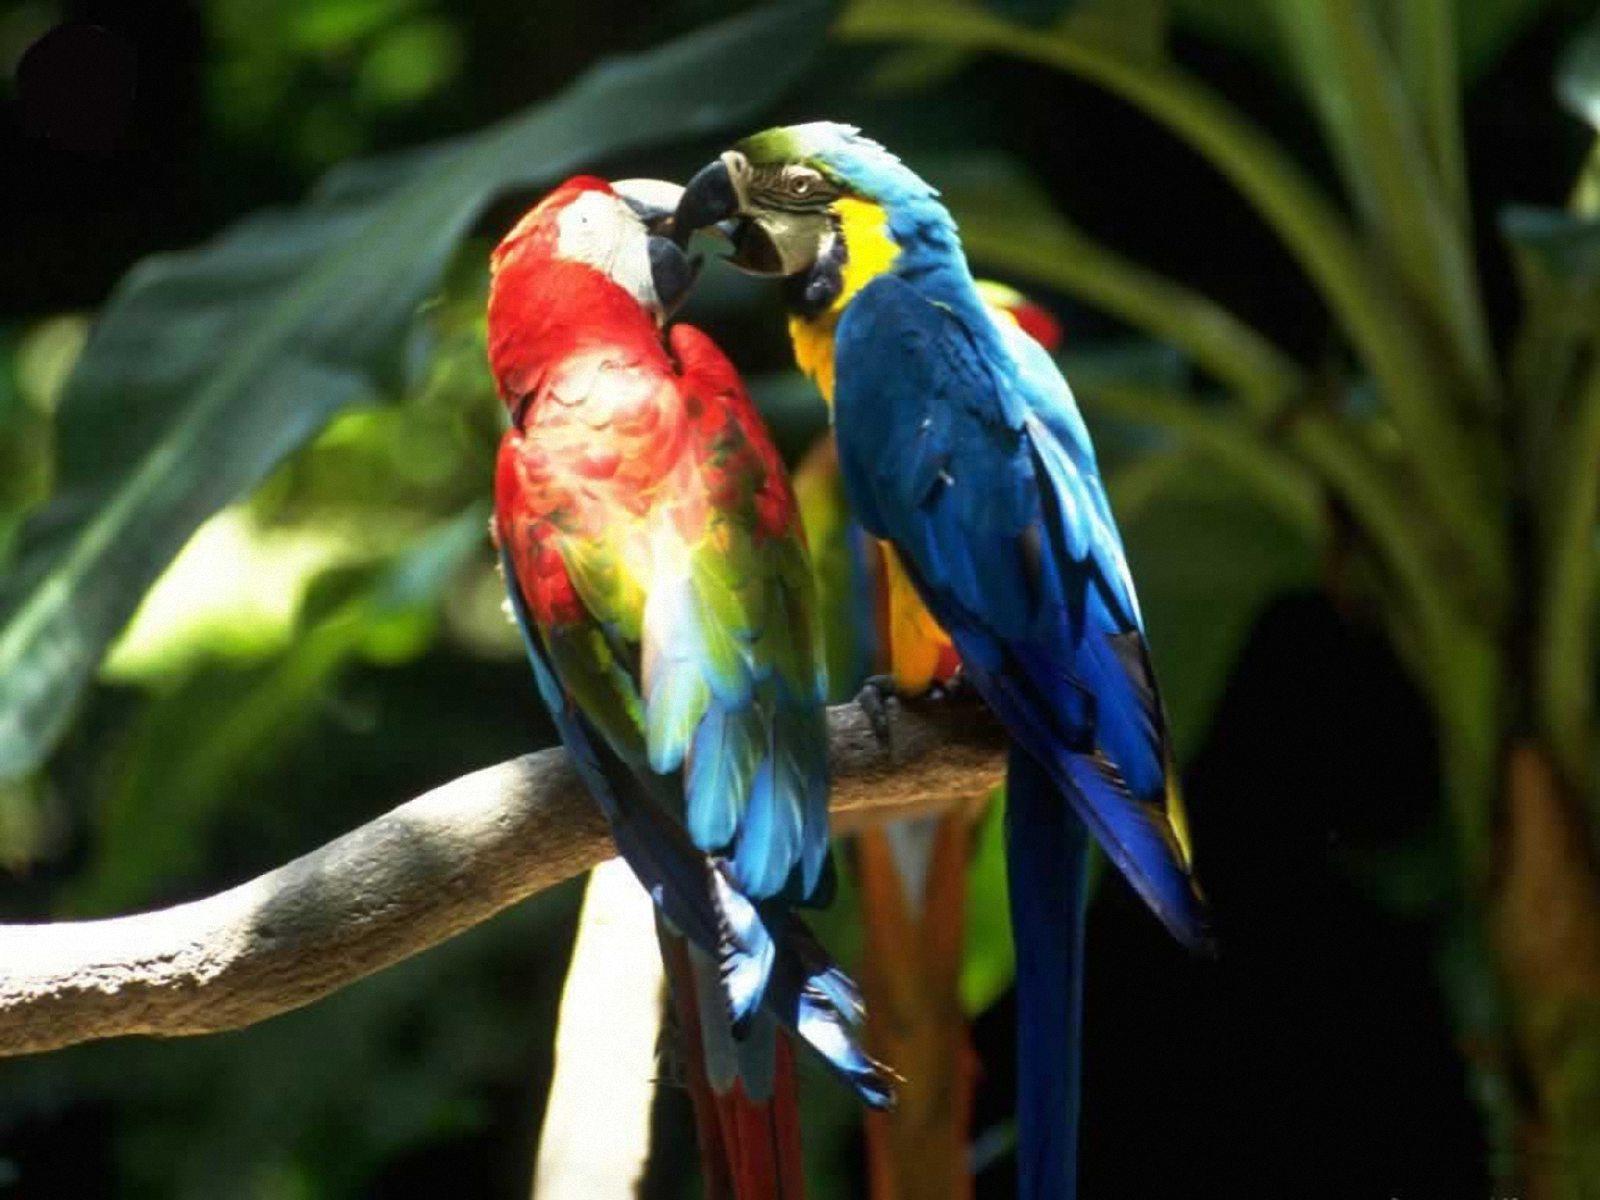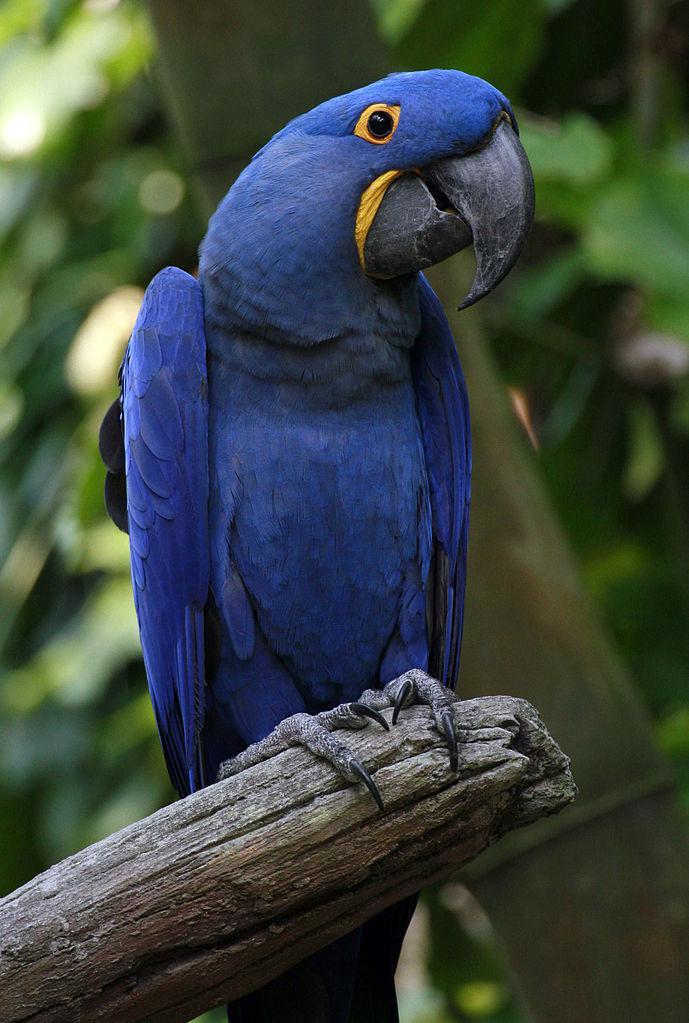The first image is the image on the left, the second image is the image on the right. Considering the images on both sides, is "In one image, a single blue parrot is sitting on a perch." valid? Answer yes or no. Yes. 